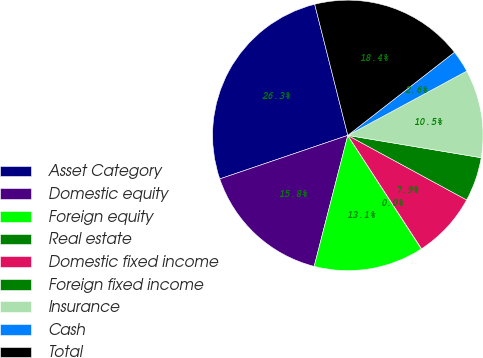Convert chart to OTSL. <chart><loc_0><loc_0><loc_500><loc_500><pie_chart><fcel>Asset Category<fcel>Domestic equity<fcel>Foreign equity<fcel>Real estate<fcel>Domestic fixed income<fcel>Foreign fixed income<fcel>Insurance<fcel>Cash<fcel>Total<nl><fcel>26.28%<fcel>15.78%<fcel>13.15%<fcel>0.03%<fcel>7.9%<fcel>5.28%<fcel>10.53%<fcel>2.65%<fcel>18.4%<nl></chart> 